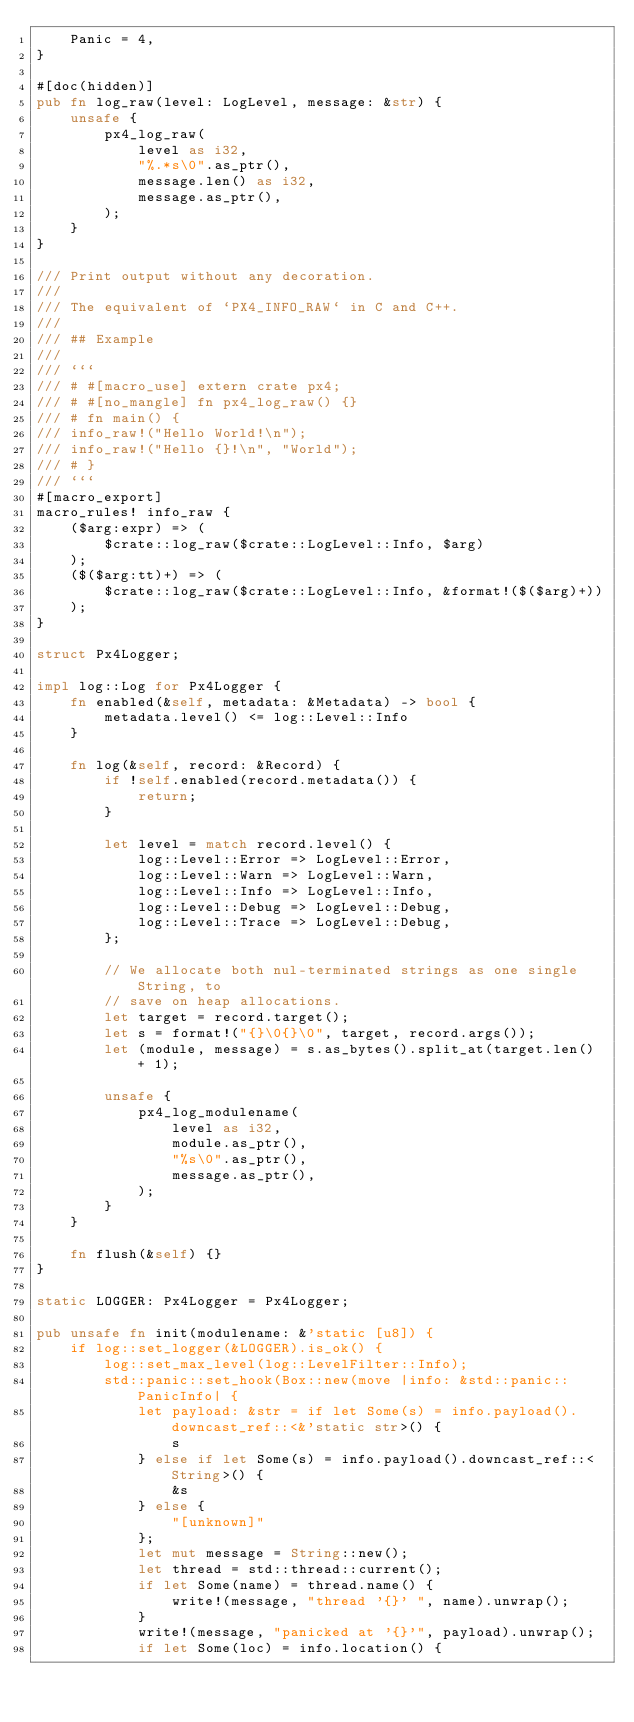Convert code to text. <code><loc_0><loc_0><loc_500><loc_500><_Rust_>	Panic = 4,
}

#[doc(hidden)]
pub fn log_raw(level: LogLevel, message: &str) {
	unsafe {
		px4_log_raw(
			level as i32,
			"%.*s\0".as_ptr(),
			message.len() as i32,
			message.as_ptr(),
		);
	}
}

/// Print output without any decoration.
///
/// The equivalent of `PX4_INFO_RAW` in C and C++.
///
/// ## Example
///
/// ```
/// # #[macro_use] extern crate px4;
/// # #[no_mangle] fn px4_log_raw() {}
/// # fn main() {
/// info_raw!("Hello World!\n");
/// info_raw!("Hello {}!\n", "World");
/// # }
/// ```
#[macro_export]
macro_rules! info_raw {
	($arg:expr) => (
		$crate::log_raw($crate::LogLevel::Info, $arg)
	);
	($($arg:tt)+) => (
		$crate::log_raw($crate::LogLevel::Info, &format!($($arg)+))
	);
}

struct Px4Logger;

impl log::Log for Px4Logger {
	fn enabled(&self, metadata: &Metadata) -> bool {
		metadata.level() <= log::Level::Info
	}

	fn log(&self, record: &Record) {
		if !self.enabled(record.metadata()) {
			return;
		}

		let level = match record.level() {
			log::Level::Error => LogLevel::Error,
			log::Level::Warn => LogLevel::Warn,
			log::Level::Info => LogLevel::Info,
			log::Level::Debug => LogLevel::Debug,
			log::Level::Trace => LogLevel::Debug,
		};

		// We allocate both nul-terminated strings as one single String, to
		// save on heap allocations.
		let target = record.target();
		let s = format!("{}\0{}\0", target, record.args());
		let (module, message) = s.as_bytes().split_at(target.len() + 1);

		unsafe {
			px4_log_modulename(
				level as i32,
				module.as_ptr(),
				"%s\0".as_ptr(),
				message.as_ptr(),
			);
		}
	}

	fn flush(&self) {}
}

static LOGGER: Px4Logger = Px4Logger;

pub unsafe fn init(modulename: &'static [u8]) {
	if log::set_logger(&LOGGER).is_ok() {
		log::set_max_level(log::LevelFilter::Info);
		std::panic::set_hook(Box::new(move |info: &std::panic::PanicInfo| {
			let payload: &str = if let Some(s) = info.payload().downcast_ref::<&'static str>() {
				s
			} else if let Some(s) = info.payload().downcast_ref::<String>() {
				&s
			} else {
				"[unknown]"
			};
			let mut message = String::new();
			let thread = std::thread::current();
			if let Some(name) = thread.name() {
				write!(message, "thread '{}' ", name).unwrap();
			}
			write!(message, "panicked at '{}'", payload).unwrap();
			if let Some(loc) = info.location() {</code> 